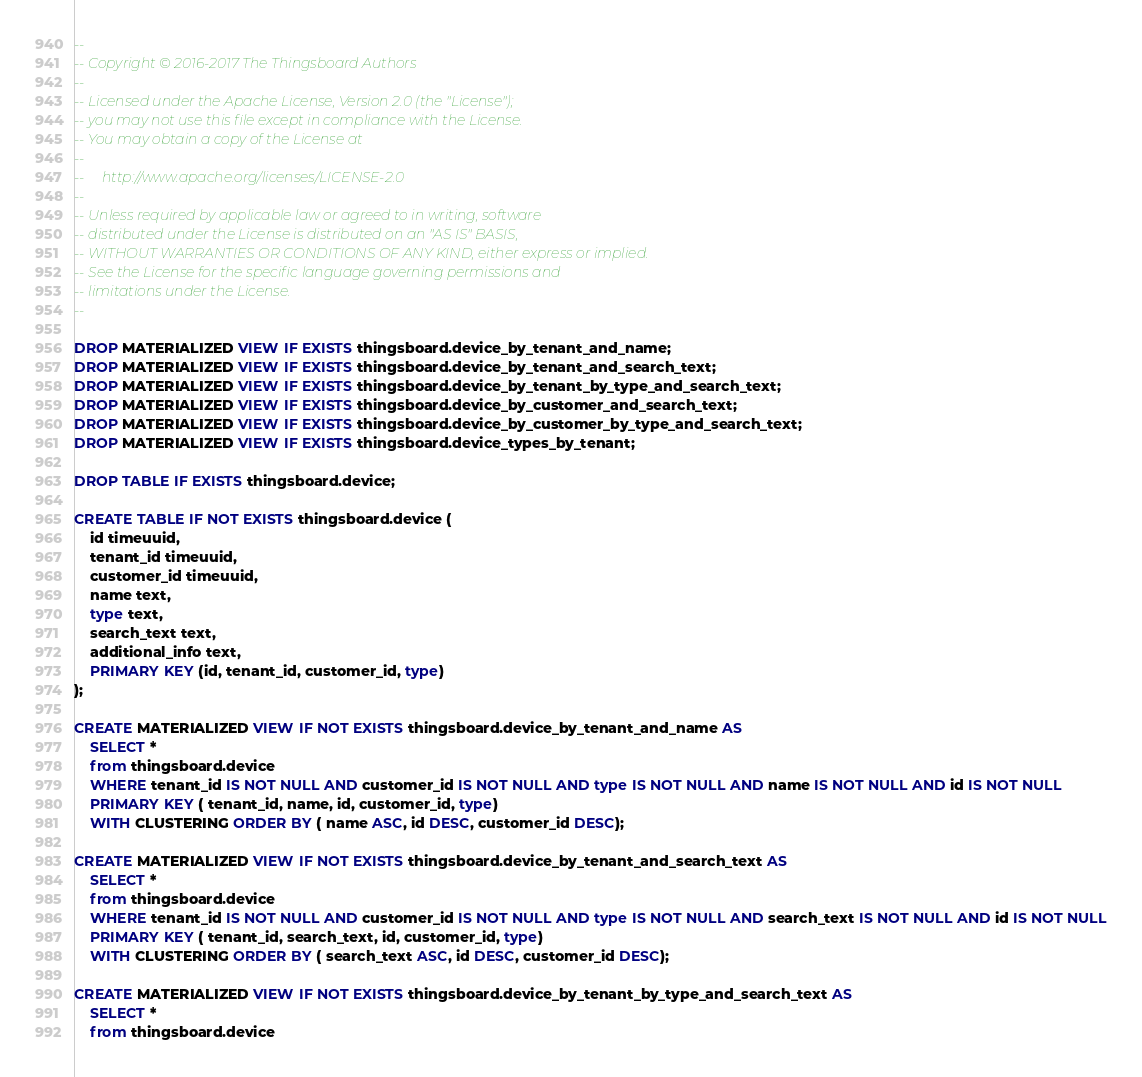Convert code to text. <code><loc_0><loc_0><loc_500><loc_500><_SQL_>--
-- Copyright © 2016-2017 The Thingsboard Authors
--
-- Licensed under the Apache License, Version 2.0 (the "License");
-- you may not use this file except in compliance with the License.
-- You may obtain a copy of the License at
--
--     http://www.apache.org/licenses/LICENSE-2.0
--
-- Unless required by applicable law or agreed to in writing, software
-- distributed under the License is distributed on an "AS IS" BASIS,
-- WITHOUT WARRANTIES OR CONDITIONS OF ANY KIND, either express or implied.
-- See the License for the specific language governing permissions and
-- limitations under the License.
--

DROP MATERIALIZED VIEW IF EXISTS thingsboard.device_by_tenant_and_name;
DROP MATERIALIZED VIEW IF EXISTS thingsboard.device_by_tenant_and_search_text;
DROP MATERIALIZED VIEW IF EXISTS thingsboard.device_by_tenant_by_type_and_search_text;
DROP MATERIALIZED VIEW IF EXISTS thingsboard.device_by_customer_and_search_text;
DROP MATERIALIZED VIEW IF EXISTS thingsboard.device_by_customer_by_type_and_search_text;
DROP MATERIALIZED VIEW IF EXISTS thingsboard.device_types_by_tenant;

DROP TABLE IF EXISTS thingsboard.device;

CREATE TABLE IF NOT EXISTS thingsboard.device (
    id timeuuid,
    tenant_id timeuuid,
    customer_id timeuuid,
    name text,
    type text,
    search_text text,
    additional_info text,
    PRIMARY KEY (id, tenant_id, customer_id, type)
);

CREATE MATERIALIZED VIEW IF NOT EXISTS thingsboard.device_by_tenant_and_name AS
    SELECT *
    from thingsboard.device
    WHERE tenant_id IS NOT NULL AND customer_id IS NOT NULL AND type IS NOT NULL AND name IS NOT NULL AND id IS NOT NULL
    PRIMARY KEY ( tenant_id, name, id, customer_id, type)
    WITH CLUSTERING ORDER BY ( name ASC, id DESC, customer_id DESC);

CREATE MATERIALIZED VIEW IF NOT EXISTS thingsboard.device_by_tenant_and_search_text AS
    SELECT *
    from thingsboard.device
    WHERE tenant_id IS NOT NULL AND customer_id IS NOT NULL AND type IS NOT NULL AND search_text IS NOT NULL AND id IS NOT NULL
    PRIMARY KEY ( tenant_id, search_text, id, customer_id, type)
    WITH CLUSTERING ORDER BY ( search_text ASC, id DESC, customer_id DESC);

CREATE MATERIALIZED VIEW IF NOT EXISTS thingsboard.device_by_tenant_by_type_and_search_text AS
    SELECT *
    from thingsboard.device</code> 